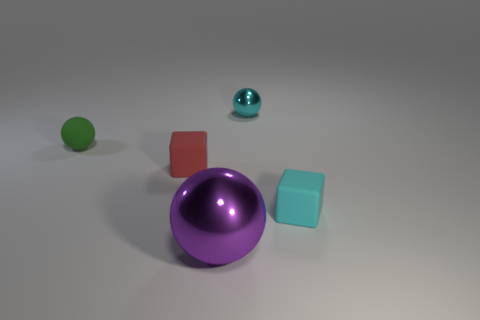Do the purple sphere in front of the red rubber object and the thing that is on the left side of the red object have the same size?
Make the answer very short. No. There is a cyan thing that is the same material as the green sphere; what is its shape?
Provide a succinct answer. Cube. Is there any other thing that is the same shape as the green thing?
Your answer should be very brief. Yes. There is a metallic ball in front of the metallic ball that is on the right side of the metal thing in front of the cyan rubber thing; what color is it?
Your answer should be compact. Purple. Are there fewer purple metal balls that are left of the tiny green matte thing than tiny rubber spheres that are on the left side of the red thing?
Ensure brevity in your answer.  Yes. Is the shape of the cyan rubber thing the same as the red rubber thing?
Give a very brief answer. Yes. How many balls are the same size as the cyan matte object?
Ensure brevity in your answer.  2. Are there fewer cyan things in front of the purple object than green balls?
Offer a very short reply. Yes. There is a rubber object in front of the block behind the small cyan cube; how big is it?
Provide a succinct answer. Small. How many things are tiny balls or green shiny cylinders?
Keep it short and to the point. 2. 